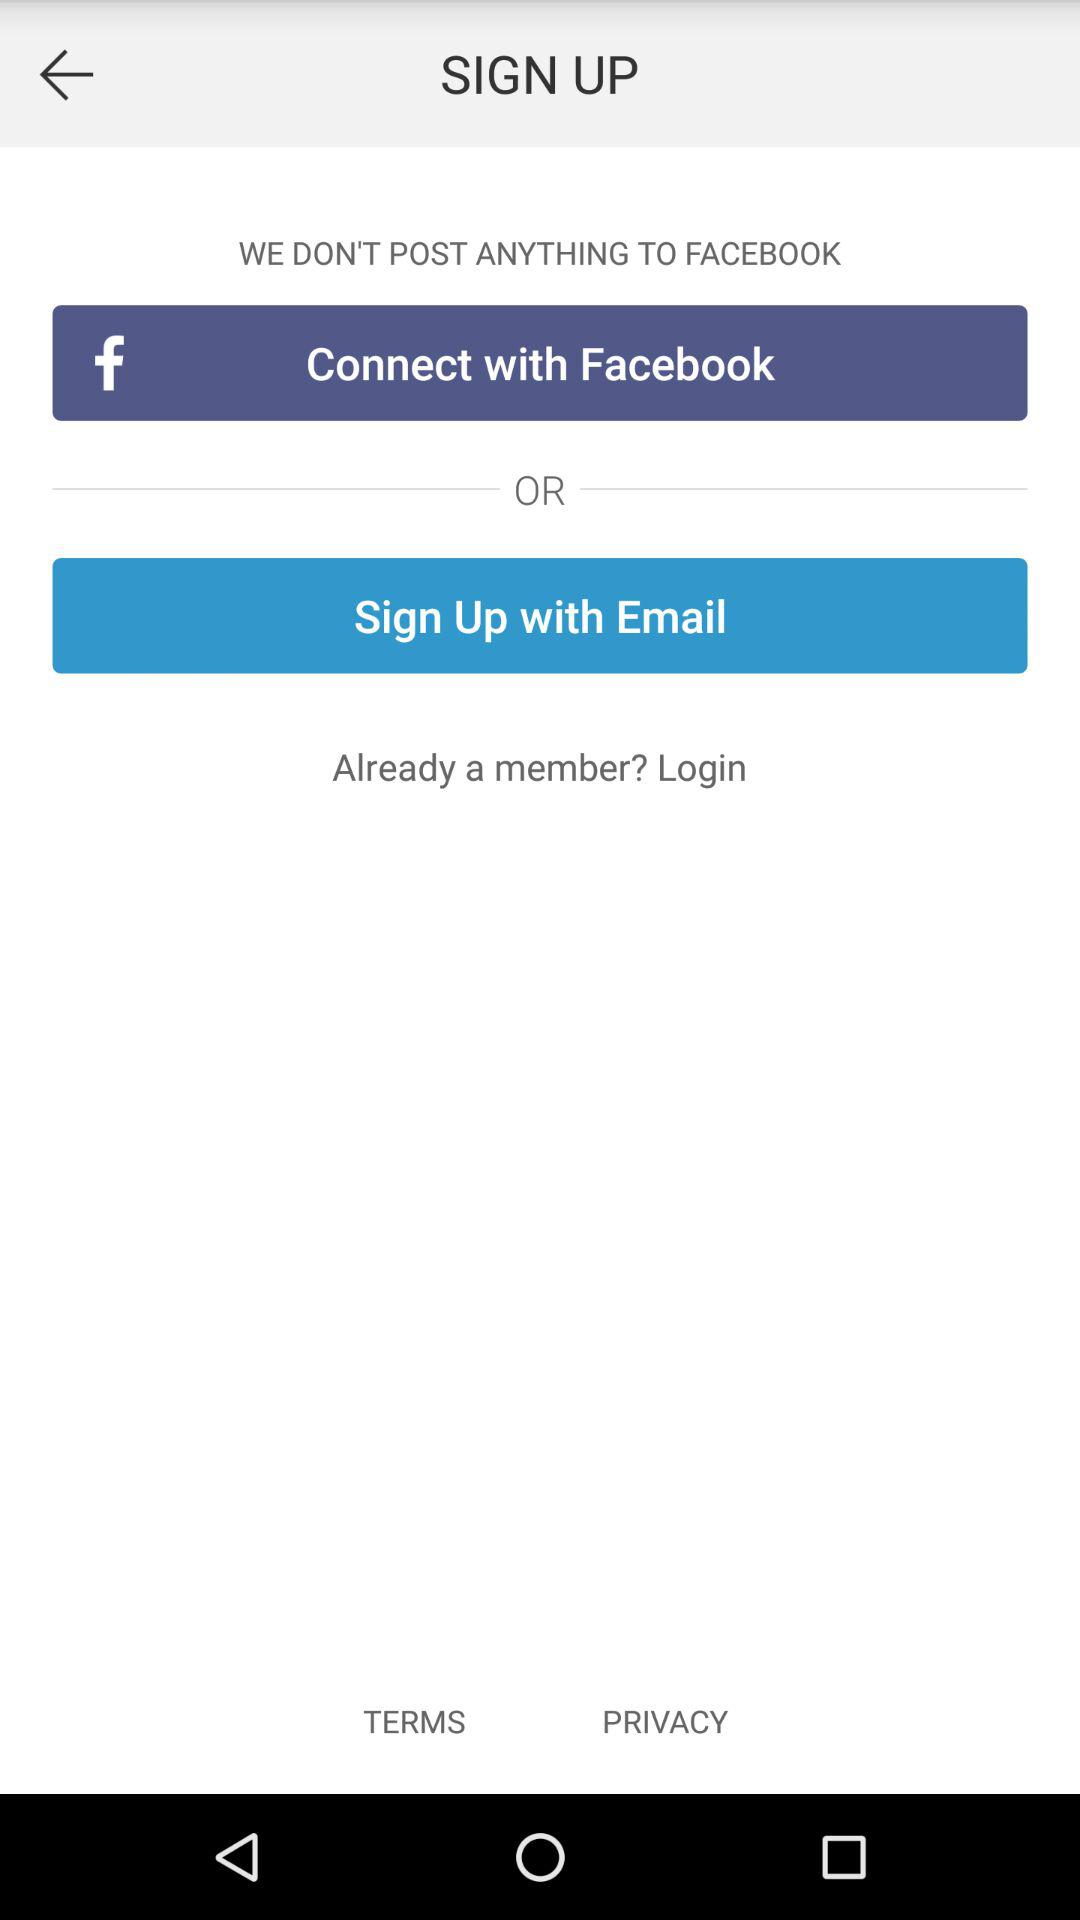What are the different options to sign up? The sign up option is "Email". 